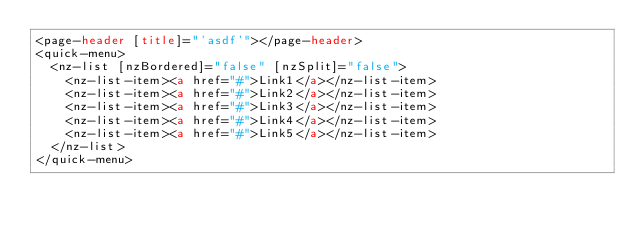<code> <loc_0><loc_0><loc_500><loc_500><_HTML_><page-header [title]="'asdf'"></page-header>
<quick-menu>
  <nz-list [nzBordered]="false" [nzSplit]="false">
    <nz-list-item><a href="#">Link1</a></nz-list-item>
    <nz-list-item><a href="#">Link2</a></nz-list-item>
    <nz-list-item><a href="#">Link3</a></nz-list-item>
    <nz-list-item><a href="#">Link4</a></nz-list-item>
    <nz-list-item><a href="#">Link5</a></nz-list-item>
  </nz-list>
</quick-menu>
</code> 